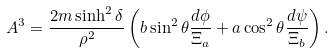Convert formula to latex. <formula><loc_0><loc_0><loc_500><loc_500>A ^ { 3 } = \frac { 2 m \sinh ^ { 2 } \delta } { \rho ^ { 2 } } \left ( b \sin ^ { 2 } \theta \frac { d \phi } { \Xi _ { a } } + a \cos ^ { 2 } \theta \frac { d \psi } { \Xi _ { b } } \right ) .</formula> 